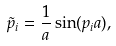Convert formula to latex. <formula><loc_0><loc_0><loc_500><loc_500>\tilde { p } _ { i } = \frac { 1 } { a } \sin ( p _ { i } a ) ,</formula> 